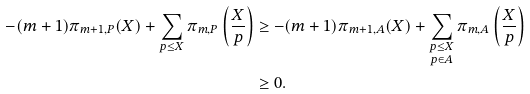<formula> <loc_0><loc_0><loc_500><loc_500>- ( m + 1 ) \pi _ { m + 1 , P } ( X ) + \sum _ { p \leq X } \pi _ { m , P } \left ( \frac { X } { p } \right ) & \geq - ( m + 1 ) \pi _ { m + 1 , A } ( X ) + \sum _ { \substack { p \leq X \\ p \in A } } \pi _ { m , A } \left ( \frac { X } { p } \right ) \\ & \geq 0 .</formula> 